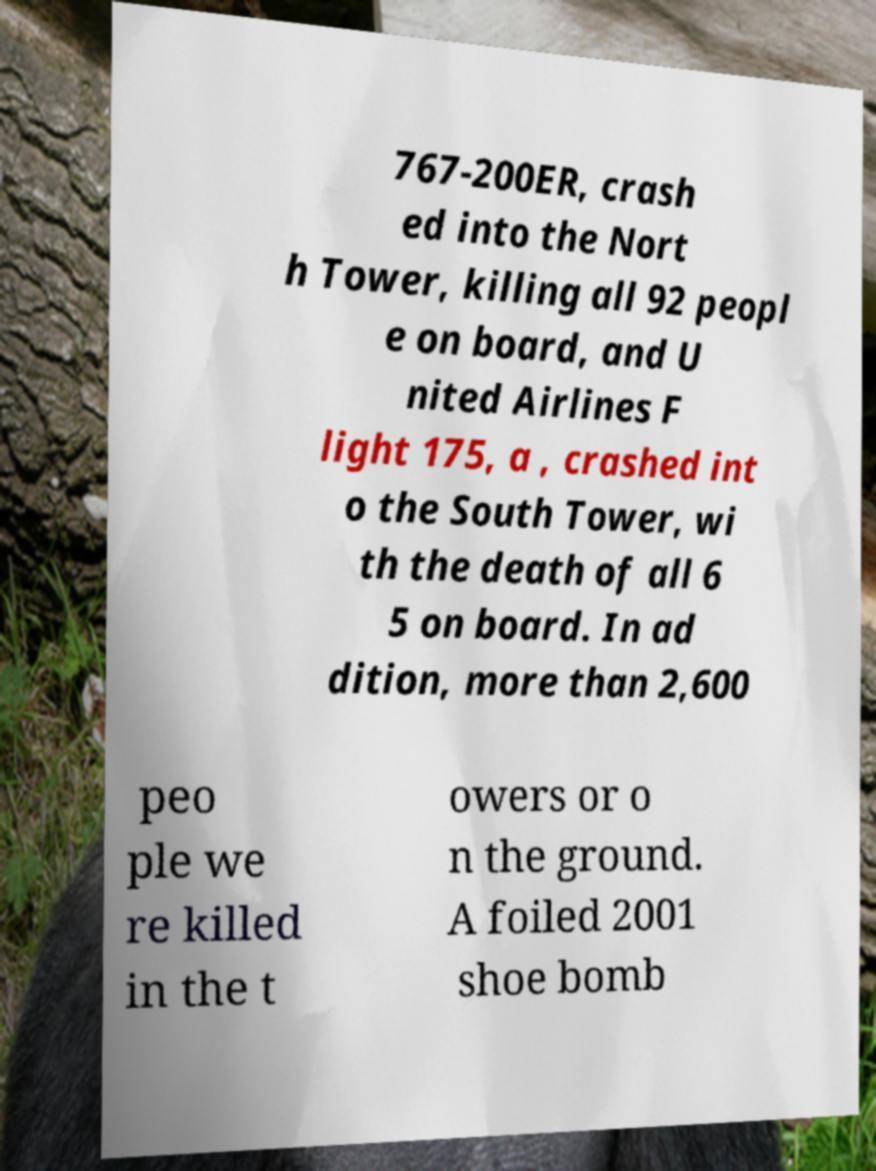Can you accurately transcribe the text from the provided image for me? 767-200ER, crash ed into the Nort h Tower, killing all 92 peopl e on board, and U nited Airlines F light 175, a , crashed int o the South Tower, wi th the death of all 6 5 on board. In ad dition, more than 2,600 peo ple we re killed in the t owers or o n the ground. A foiled 2001 shoe bomb 